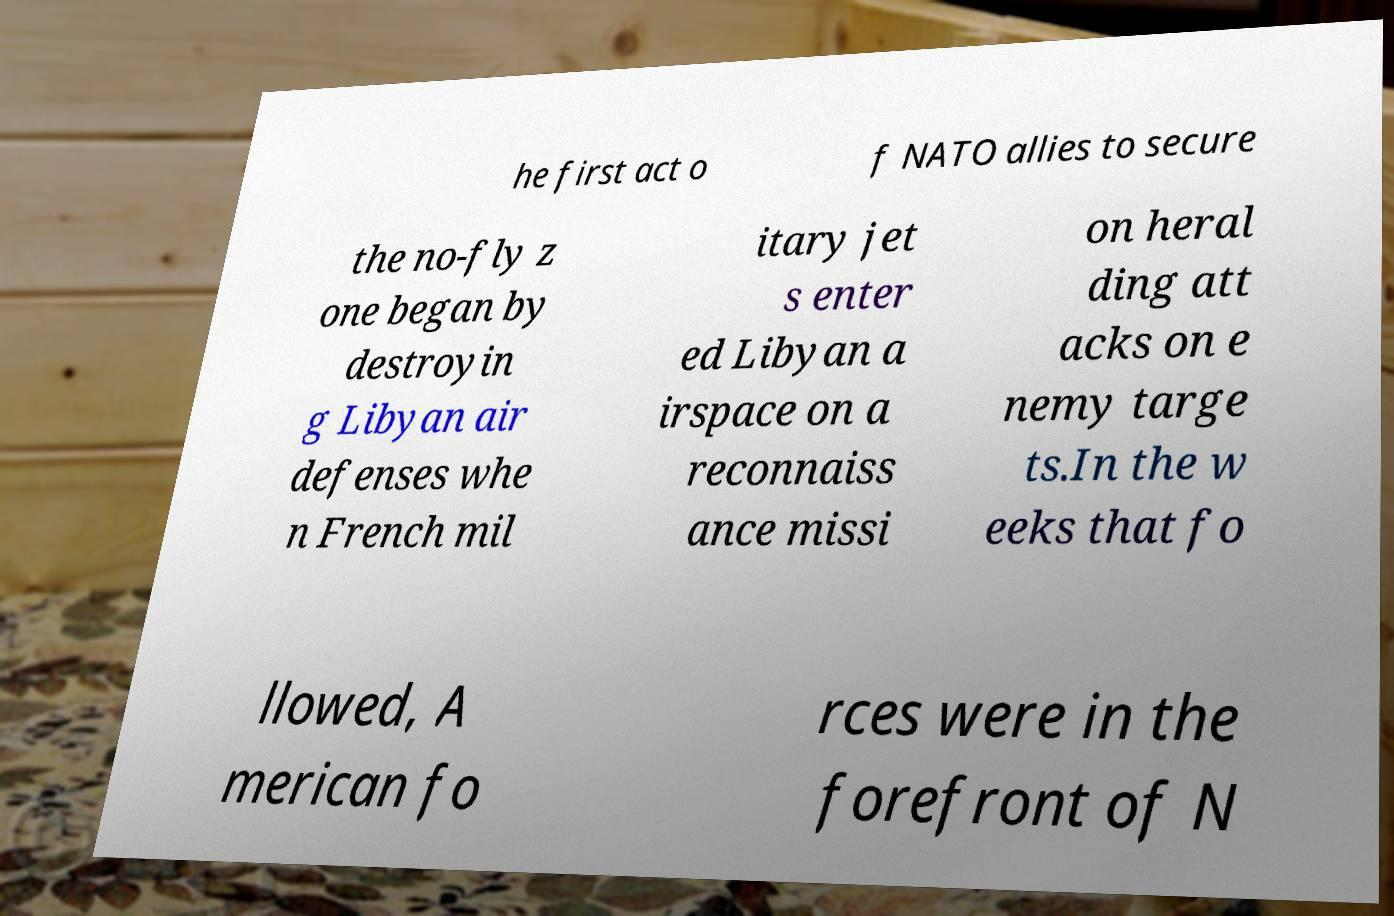I need the written content from this picture converted into text. Can you do that? he first act o f NATO allies to secure the no-fly z one began by destroyin g Libyan air defenses whe n French mil itary jet s enter ed Libyan a irspace on a reconnaiss ance missi on heral ding att acks on e nemy targe ts.In the w eeks that fo llowed, A merican fo rces were in the forefront of N 